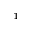Convert formula to latex. <formula><loc_0><loc_0><loc_500><loc_500>^ { 1 }</formula> 